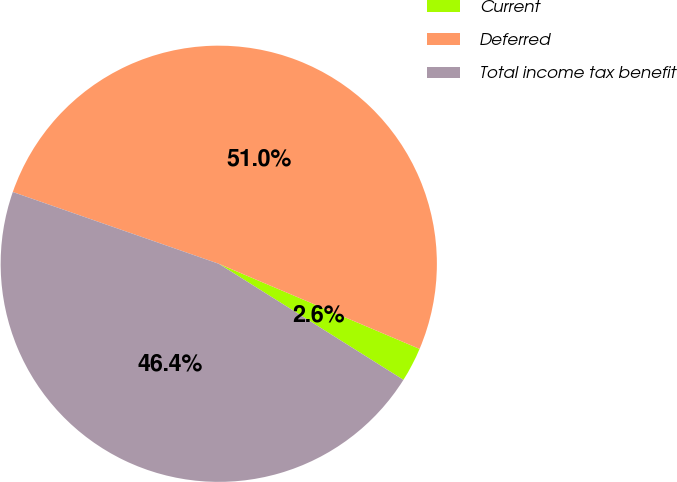Convert chart to OTSL. <chart><loc_0><loc_0><loc_500><loc_500><pie_chart><fcel>Current<fcel>Deferred<fcel>Total income tax benefit<nl><fcel>2.55%<fcel>51.04%<fcel>46.4%<nl></chart> 